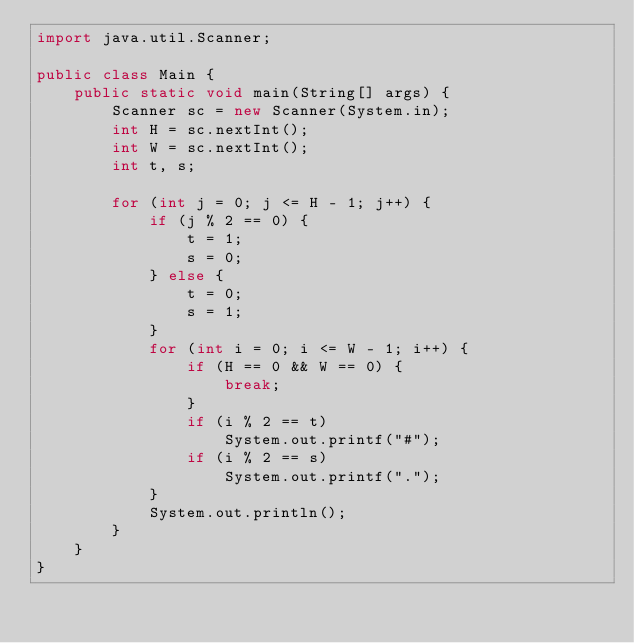<code> <loc_0><loc_0><loc_500><loc_500><_Java_>import java.util.Scanner;

public class Main {
	public static void main(String[] args) {
		Scanner sc = new Scanner(System.in);
		int H = sc.nextInt();
		int W = sc.nextInt();
		int t, s;

		for (int j = 0; j <= H - 1; j++) {
			if (j % 2 == 0) {
				t = 1;
				s = 0;
			} else {
				t = 0;
				s = 1;
			}
			for (int i = 0; i <= W - 1; i++) {
				if (H == 0 && W == 0) {
					break;
				}
				if (i % 2 == t)
					System.out.printf("#");
				if (i % 2 == s)
					System.out.printf(".");
			}
			System.out.println();
		}
	}
}</code> 